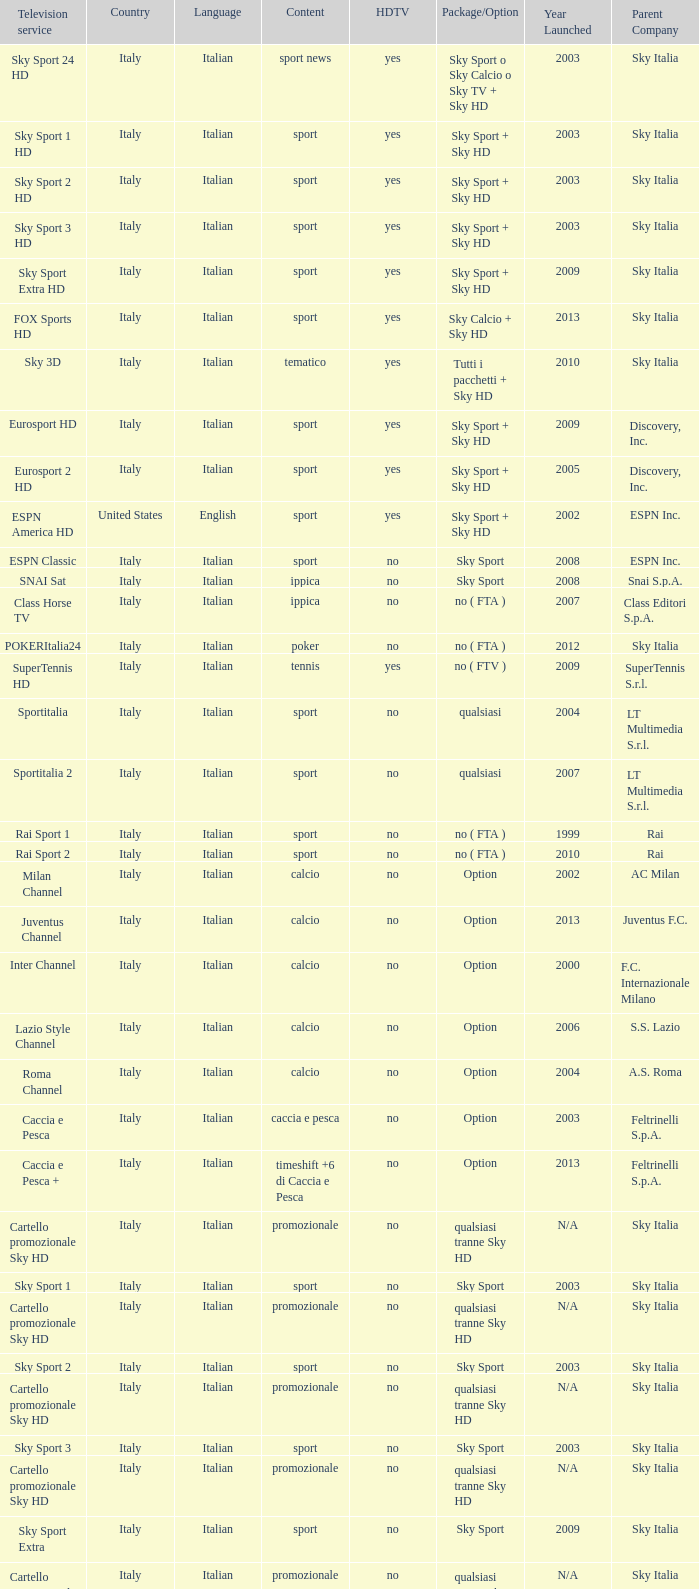What does the term package/option mean when discussing tennis content? No ( ftv ). 